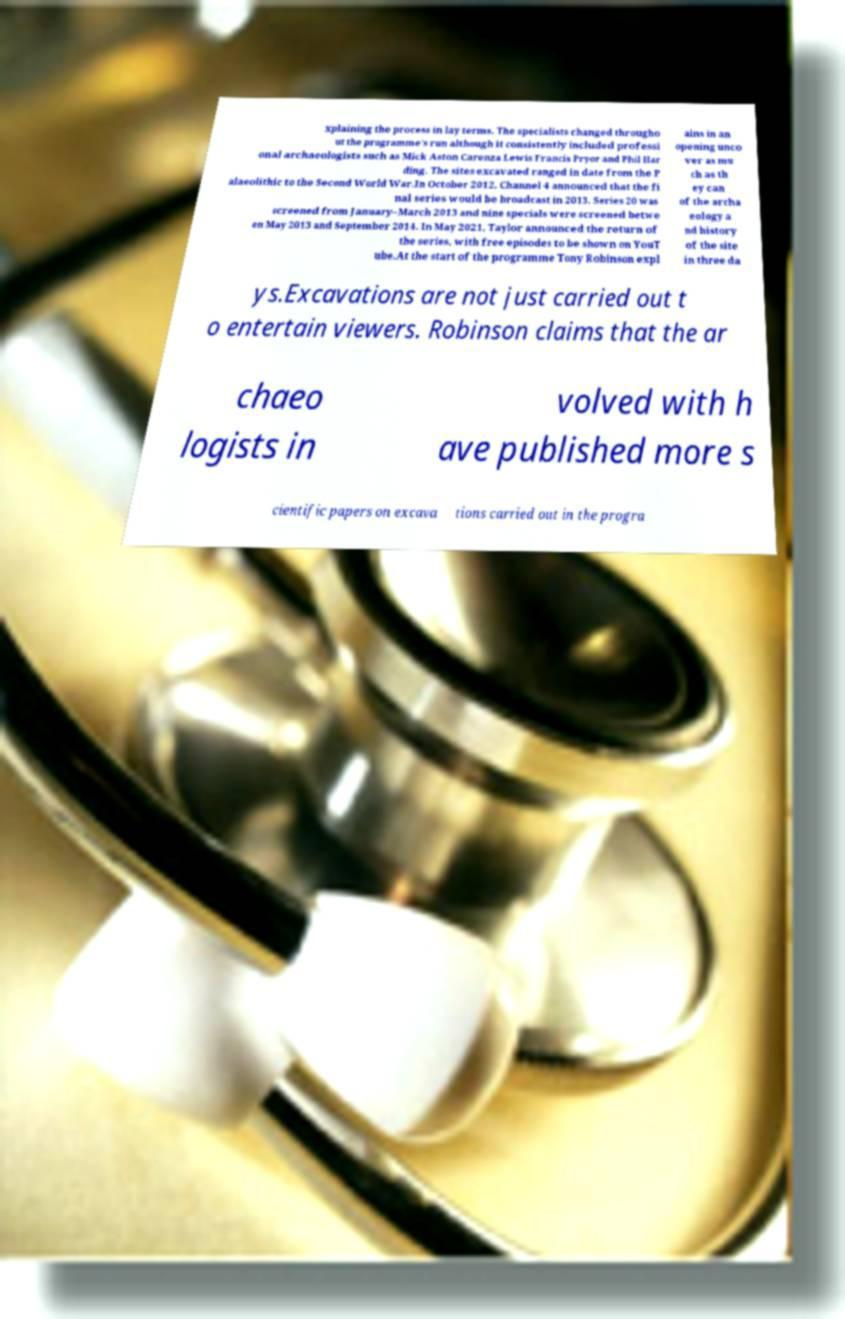I need the written content from this picture converted into text. Can you do that? xplaining the process in lay terms. The specialists changed througho ut the programme's run although it consistently included professi onal archaeologists such as Mick Aston Carenza Lewis Francis Pryor and Phil Har ding. The sites excavated ranged in date from the P alaeolithic to the Second World War.In October 2012, Channel 4 announced that the fi nal series would be broadcast in 2013. Series 20 was screened from January–March 2013 and nine specials were screened betwe en May 2013 and September 2014. In May 2021, Taylor announced the return of the series, with free episodes to be shown on YouT ube.At the start of the programme Tony Robinson expl ains in an opening unco ver as mu ch as th ey can of the archa eology a nd history of the site in three da ys.Excavations are not just carried out t o entertain viewers. Robinson claims that the ar chaeo logists in volved with h ave published more s cientific papers on excava tions carried out in the progra 